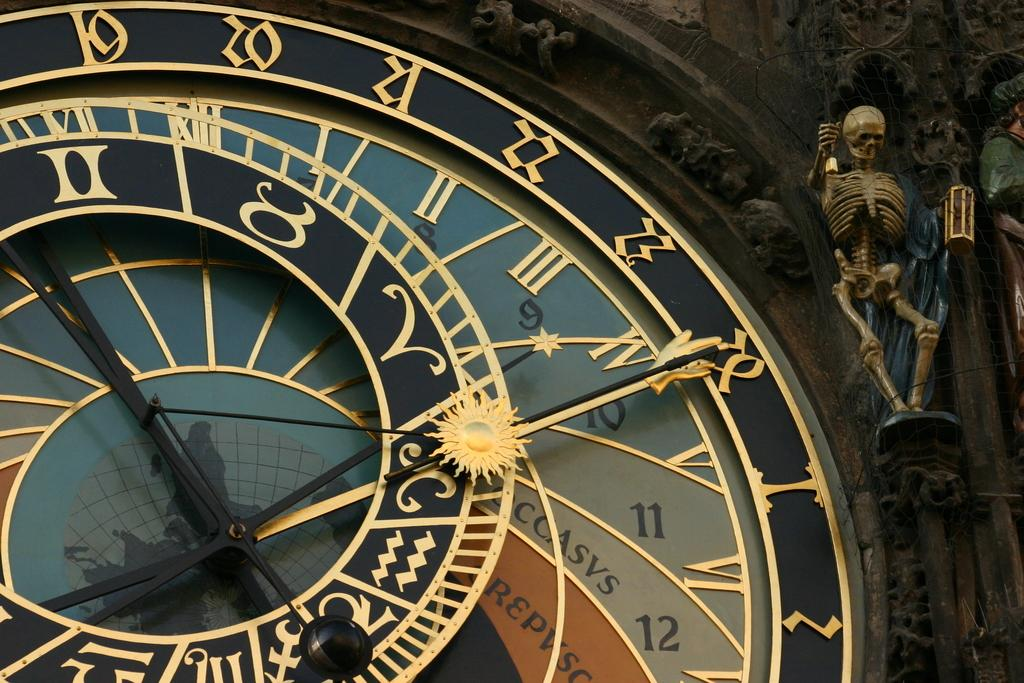<image>
Give a short and clear explanation of the subsequent image. Multicolored clock with the letters "REPVSO" on the orange part of the face. 